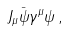<formula> <loc_0><loc_0><loc_500><loc_500>J _ { \mu } \bar { \psi } \gamma ^ { \mu } \psi \, ,</formula> 